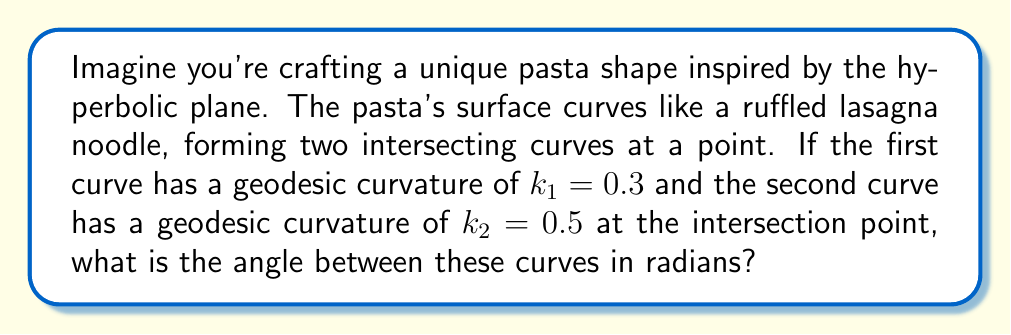Solve this math problem. Let's approach this step-by-step:

1) In hyperbolic geometry, the angle between two intersecting curves is related to their geodesic curvatures at the point of intersection.

2) The formula for the angle $\theta$ between two curves with geodesic curvatures $k_1$ and $k_2$ in hyperbolic geometry is:

   $$\cos \theta = \frac{k_1 k_2 - 1}{\sqrt{(k_1^2 - 1)(k_2^2 - 1)}}$$

3) We are given $k_1 = 0.3$ and $k_2 = 0.5$. Let's substitute these values:

   $$\cos \theta = \frac{(0.3)(0.5) - 1}{\sqrt{(0.3^2 - 1)(0.5^2 - 1)}}$$

4) Let's calculate the numerator:
   $(0.3)(0.5) - 1 = 0.15 - 1 = -0.85$

5) Now the denominator:
   $\sqrt{(0.3^2 - 1)(0.5^2 - 1)} = \sqrt{(-0.91)(-0.75)} = \sqrt{0.6825} \approx 0.8262$

6) Putting it together:

   $$\cos \theta = \frac{-0.85}{0.8262} \approx -1.0288$$

7) To find $\theta$, we need to take the inverse cosine (arccos):

   $$\theta = \arccos(-1.0288) \approx 3.0052 \text{ radians}$$

Note: The result is slightly above $\pi$ due to rounding in our calculations. In a perfect hyperbolic plane, this angle would be exactly $\pi$ radians.
Answer: $3.0052$ radians 